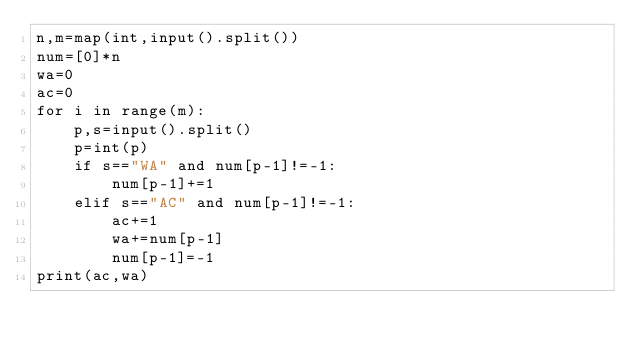Convert code to text. <code><loc_0><loc_0><loc_500><loc_500><_Python_>n,m=map(int,input().split())
num=[0]*n
wa=0
ac=0
for i in range(m):
    p,s=input().split()
    p=int(p)
    if s=="WA" and num[p-1]!=-1:
        num[p-1]+=1
    elif s=="AC" and num[p-1]!=-1:
        ac+=1
        wa+=num[p-1]
        num[p-1]=-1
print(ac,wa)
</code> 